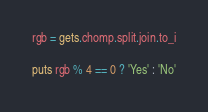<code> <loc_0><loc_0><loc_500><loc_500><_Ruby_>rgb = gets.chomp.split.join.to_i

puts rgb % 4 == 0 ? 'Yes' : 'No'</code> 